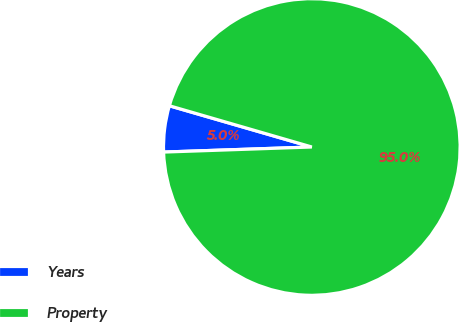Convert chart. <chart><loc_0><loc_0><loc_500><loc_500><pie_chart><fcel>Years<fcel>Property<nl><fcel>5.03%<fcel>94.97%<nl></chart> 